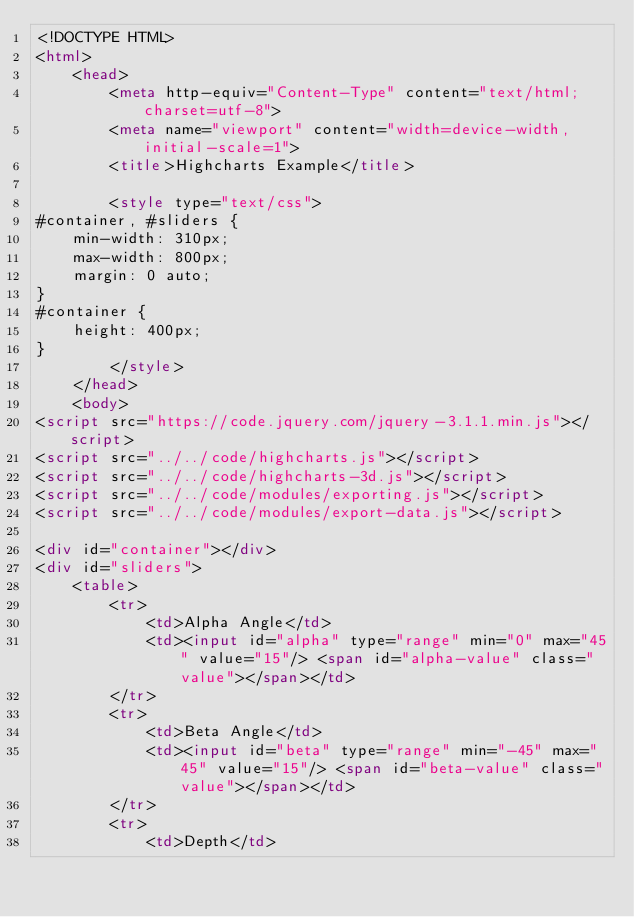<code> <loc_0><loc_0><loc_500><loc_500><_HTML_><!DOCTYPE HTML>
<html>
	<head>
		<meta http-equiv="Content-Type" content="text/html; charset=utf-8">
		<meta name="viewport" content="width=device-width, initial-scale=1">
		<title>Highcharts Example</title>

		<style type="text/css">
#container, #sliders {
    min-width: 310px; 
    max-width: 800px;
    margin: 0 auto;
}
#container {
    height: 400px; 
}
		</style>
	</head>
	<body>
<script src="https://code.jquery.com/jquery-3.1.1.min.js"></script>
<script src="../../code/highcharts.js"></script>
<script src="../../code/highcharts-3d.js"></script>
<script src="../../code/modules/exporting.js"></script>
<script src="../../code/modules/export-data.js"></script>

<div id="container"></div>
<div id="sliders">
    <table>
        <tr>
        	<td>Alpha Angle</td>
        	<td><input id="alpha" type="range" min="0" max="45" value="15"/> <span id="alpha-value" class="value"></span></td>
        </tr>
        <tr>
        	<td>Beta Angle</td>
        	<td><input id="beta" type="range" min="-45" max="45" value="15"/> <span id="beta-value" class="value"></span></td>
        </tr>
        <tr>
        	<td>Depth</td></code> 